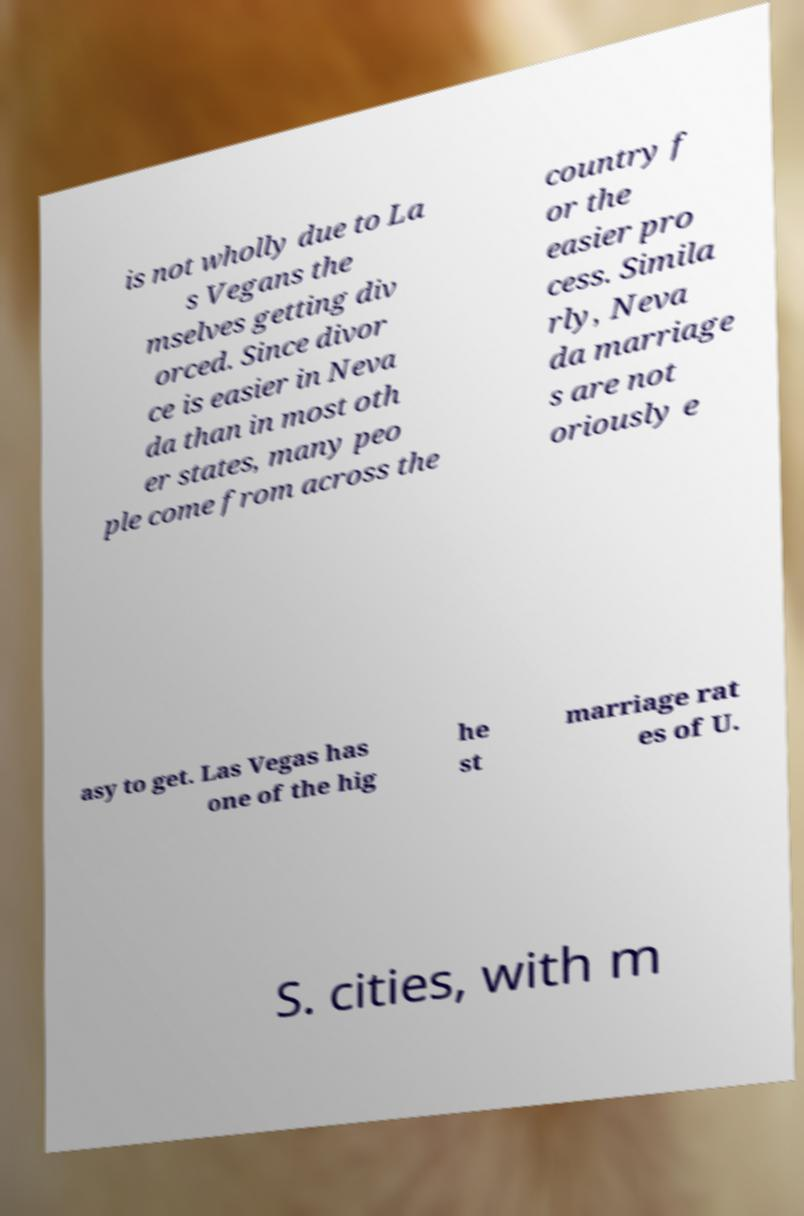Can you accurately transcribe the text from the provided image for me? is not wholly due to La s Vegans the mselves getting div orced. Since divor ce is easier in Neva da than in most oth er states, many peo ple come from across the country f or the easier pro cess. Simila rly, Neva da marriage s are not oriously e asy to get. Las Vegas has one of the hig he st marriage rat es of U. S. cities, with m 